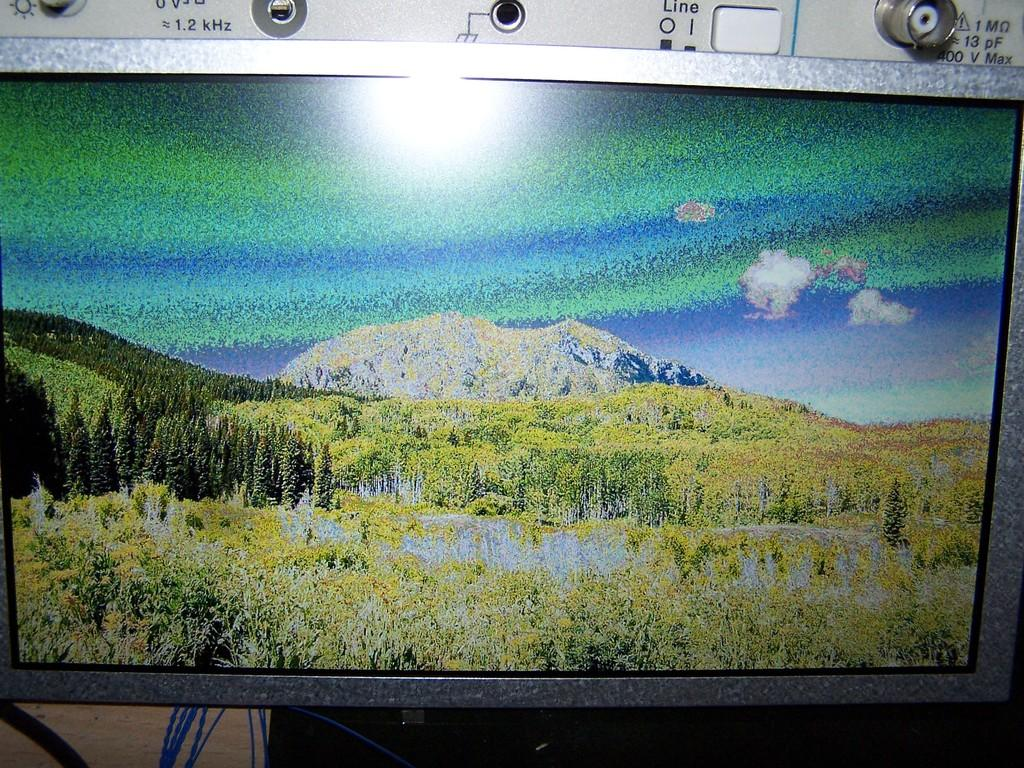Provide a one-sentence caption for the provided image. A landscape is up on a screen with the word line behind it. 